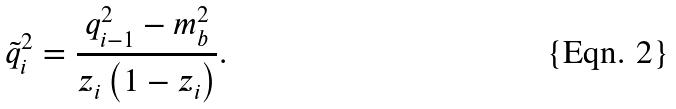Convert formula to latex. <formula><loc_0><loc_0><loc_500><loc_500>\tilde { q } _ { i } ^ { 2 } = \frac { q _ { i - 1 } ^ { 2 } - m _ { b } ^ { 2 } } { z _ { i } \left ( 1 - z _ { i } \right ) } .</formula> 